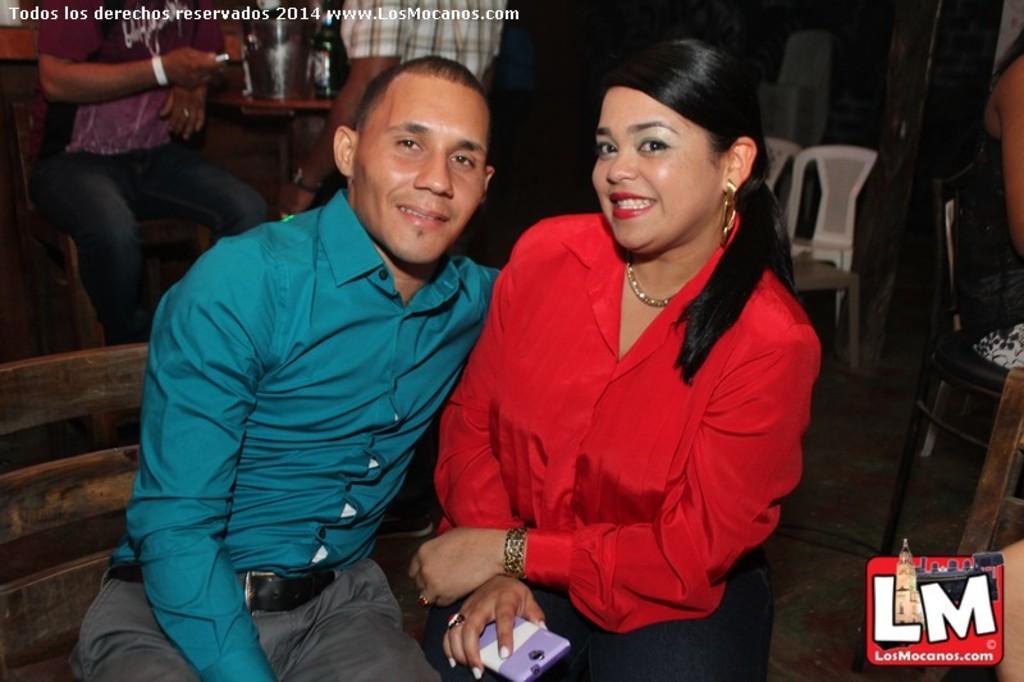Describe this image in one or two sentences. In this image there are two persons sitting on the chairs and smiling, and in the background there are another two persons sitting on the chairs, a person standing, bottles on the table and there are watermarks on the image. 